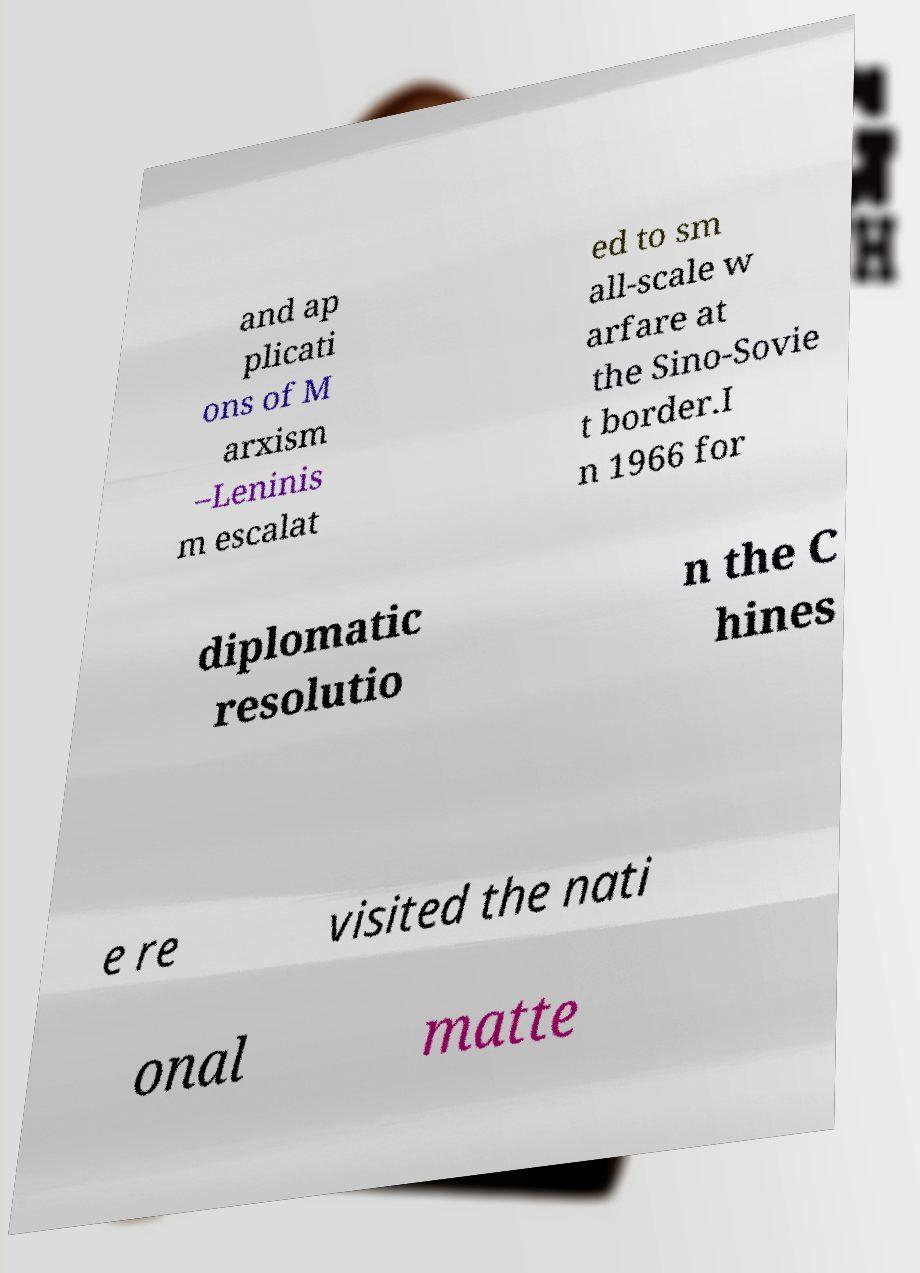Could you extract and type out the text from this image? and ap plicati ons of M arxism –Leninis m escalat ed to sm all-scale w arfare at the Sino-Sovie t border.I n 1966 for diplomatic resolutio n the C hines e re visited the nati onal matte 